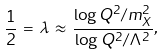<formula> <loc_0><loc_0><loc_500><loc_500>\frac { 1 } { 2 } \, = \, \lambda \, \approx \, \frac { \log Q ^ { 2 } / m _ { X } ^ { 2 } } { \log Q ^ { 2 } / \Lambda ^ { 2 } } ,</formula> 